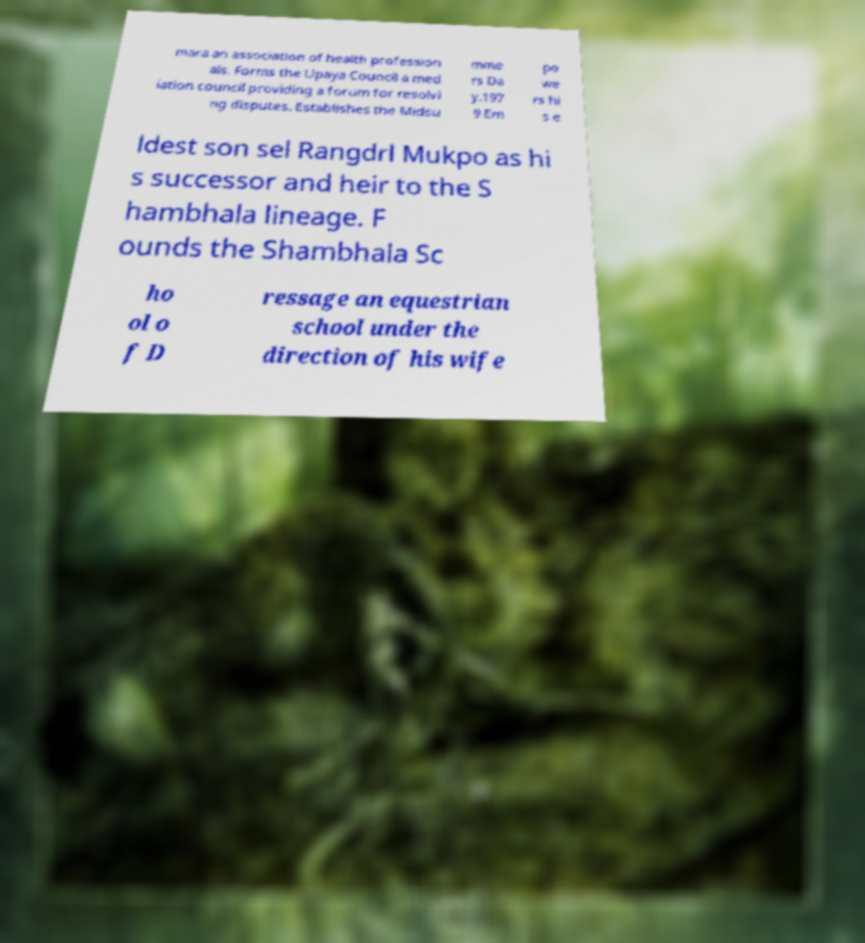What messages or text are displayed in this image? I need them in a readable, typed format. mara an association of health profession als. Forms the Upaya Council a med iation council providing a forum for resolvi ng disputes. Establishes the Midsu mme rs Da y.197 9 Em po we rs hi s e ldest son sel Rangdrl Mukpo as hi s successor and heir to the S hambhala lineage. F ounds the Shambhala Sc ho ol o f D ressage an equestrian school under the direction of his wife 